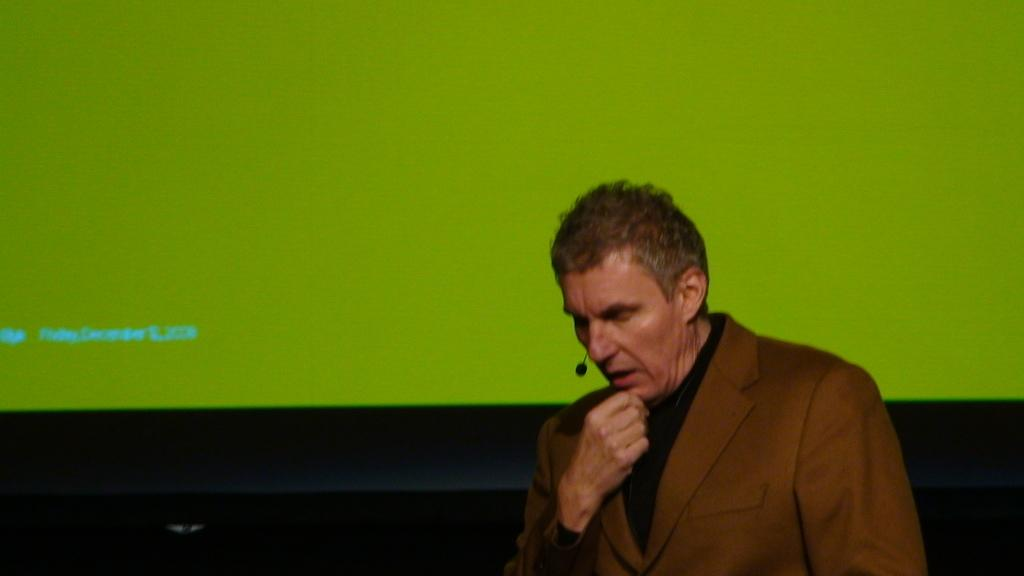What is present in the image? There is a man in the image. What can be seen in the background of the image? There is a screen with a display in the background of the image. What type of apples can be heard in the image? There are no apples present in the image, and therefore no sounds related to apples can be heard. 